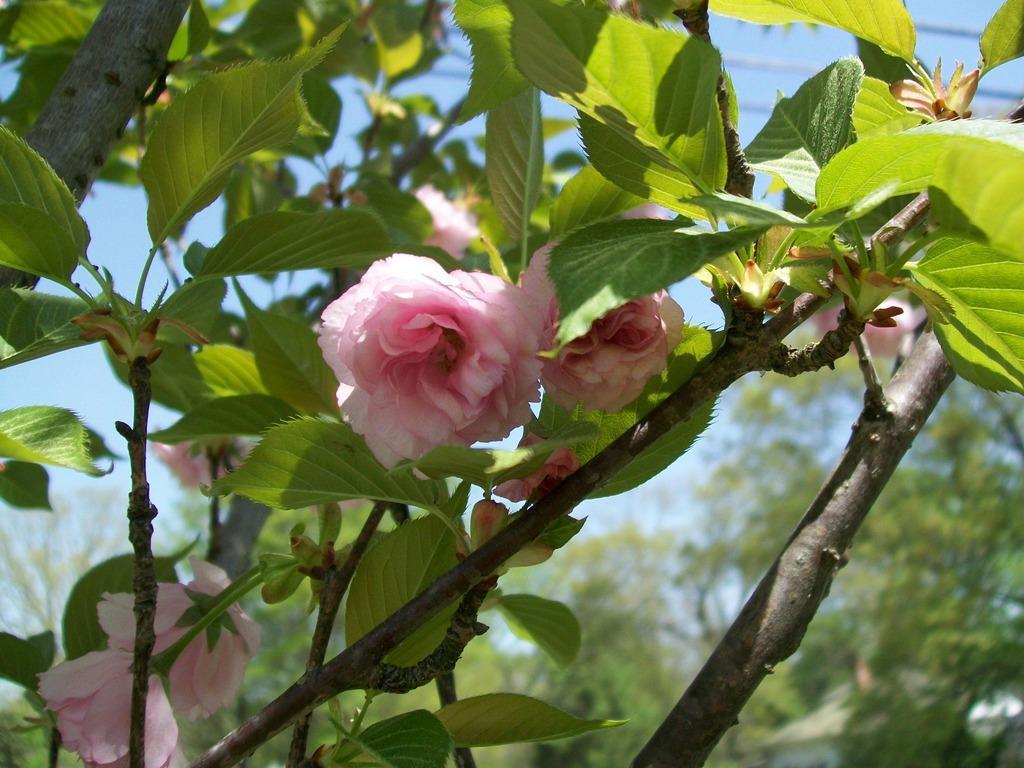Describe this image in one or two sentences. In this image I can see few flowers in pink and white color, background I can see trees in green color and the sky is in blue color. 